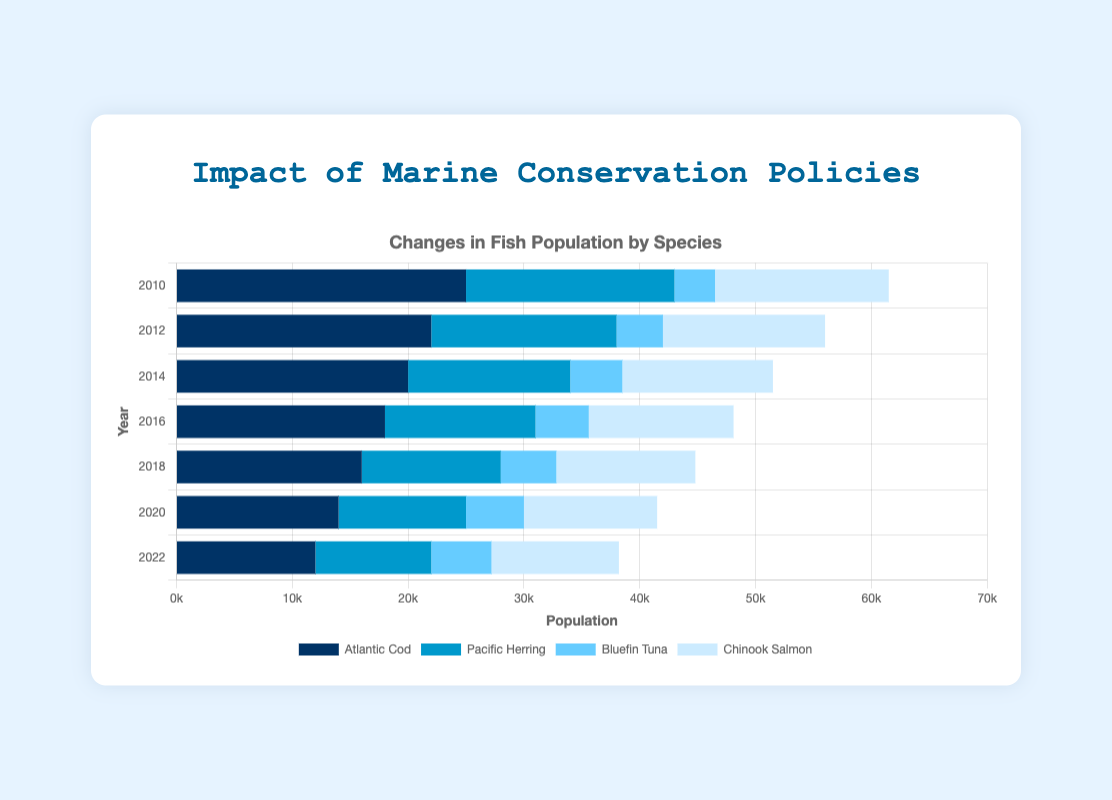Which species had the highest population in 2022? Refer to the figure and find the species with the largest bar for the year 2022. The longest bar in 2022 is for Atlantic Cod.
Answer: Atlantic Cod How many species showed a population increase between 2010 and 2022? By comparing the bar lengths for each species between 2010 and 2022, Bluefin Tuna is the only species that shows an increase.
Answer: 1 Which year had the highest total fish population? Sum the populations for all species in each year and compare the totals. The sums are: 2010 (61500), 2012 (56000), 2014 (51500), 2016 (48100), 2018 (44800), 2020 (41500), 2022 (38200). The highest total is in 2010.
Answer: 2010 Which species had their population decline by more than 10,000 from 2010 to 2022? Calculate the difference in population for each species between 2010 and 2022. Atlantic Cod (25000-12000=13000) and Pacific Herring (18000-10000=8000) show declines, but only Atlantic Cod shows a decline over 10,000.
Answer: Atlantic Cod What is the average population of Bluefin Tuna from 2010 to 2022? Sum the Bluefin Tuna populations for all years and divide by the number of years. (3500+4000+4500+4600+4800+5000+5200) / 7 = 36600 / 7 = 5228.57
Answer: 5228.57 Which species had the smallest population in any given year, and what was that population? Identify the smallest bar for any species in the figure. The smallest population is Bluefin Tuna in 2010 with 3500.
Answer: Bluefin Tuna, 3500 Which species had the most consistent population level from 2010 to 2022? Look at the bars' lengths over the years; Chinook Salmon has the least variance and the most consistent population levels.
Answer: Chinook Salmon How did the population of Chinook Salmon change from 2010 to 2022? Compare the bar lengths for Chinook Salmon in 2010 and 2022. The population decreased from 15000 to 11000.
Answer: Decreased by 4000 Which species showed the greatest percent decrease in population between 2010 and 2022? Calculate the percent decrease for each species [(Initial - Final) / Initial * 100]. Atlantic Cod has the highest percent decrease: (25000-12000)/25000 * 100 = 52%.
Answer: Atlantic Cod, 52% 